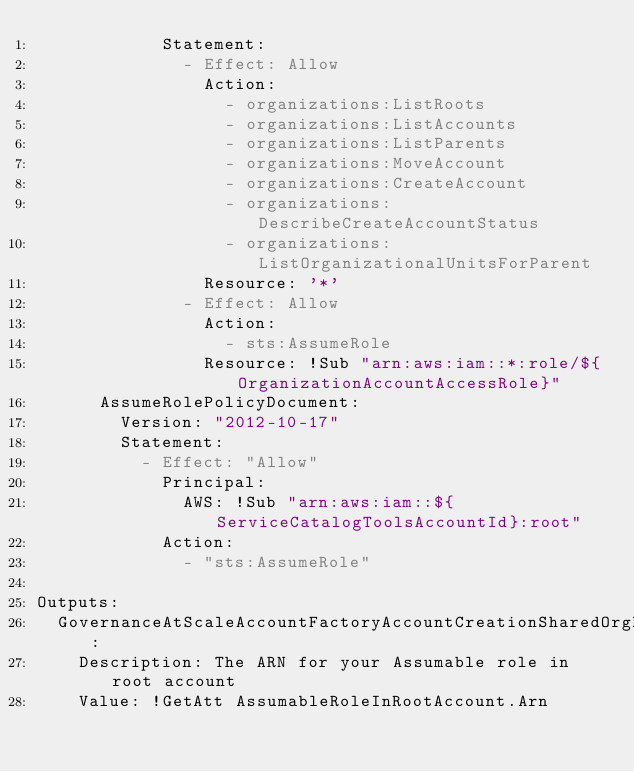Convert code to text. <code><loc_0><loc_0><loc_500><loc_500><_YAML_>            Statement:
              - Effect: Allow
                Action:
                  - organizations:ListRoots
                  - organizations:ListAccounts
                  - organizations:ListParents
                  - organizations:MoveAccount
                  - organizations:CreateAccount
                  - organizations:DescribeCreateAccountStatus
                  - organizations:ListOrganizationalUnitsForParent
                Resource: '*'
              - Effect: Allow
                Action:
                  - sts:AssumeRole
                Resource: !Sub "arn:aws:iam::*:role/${OrganizationAccountAccessRole}"
      AssumeRolePolicyDocument:
        Version: "2012-10-17"
        Statement:
          - Effect: "Allow"
            Principal:
              AWS: !Sub "arn:aws:iam::${ServiceCatalogToolsAccountId}:root"
            Action:
              - "sts:AssumeRole"

Outputs:
  GovernanceAtScaleAccountFactoryAccountCreationSharedOrgRoleArn:
    Description: The ARN for your Assumable role in root account
    Value: !GetAtt AssumableRoleInRootAccount.Arn
</code> 